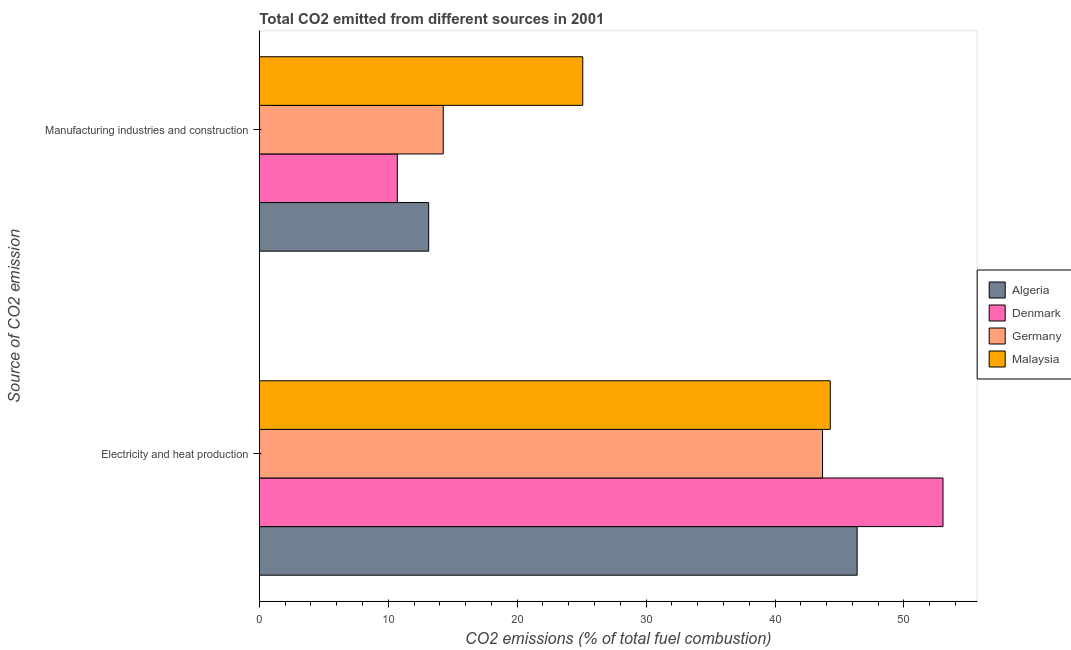How many different coloured bars are there?
Your response must be concise. 4. How many groups of bars are there?
Your response must be concise. 2. Are the number of bars per tick equal to the number of legend labels?
Keep it short and to the point. Yes. Are the number of bars on each tick of the Y-axis equal?
Ensure brevity in your answer.  Yes. How many bars are there on the 1st tick from the top?
Offer a terse response. 4. How many bars are there on the 2nd tick from the bottom?
Provide a succinct answer. 4. What is the label of the 2nd group of bars from the top?
Provide a short and direct response. Electricity and heat production. What is the co2 emissions due to manufacturing industries in Malaysia?
Offer a very short reply. 25.09. Across all countries, what is the maximum co2 emissions due to electricity and heat production?
Offer a terse response. 53.03. Across all countries, what is the minimum co2 emissions due to electricity and heat production?
Make the answer very short. 43.69. In which country was the co2 emissions due to manufacturing industries maximum?
Keep it short and to the point. Malaysia. What is the total co2 emissions due to electricity and heat production in the graph?
Make the answer very short. 187.37. What is the difference between the co2 emissions due to manufacturing industries in Malaysia and that in Denmark?
Your answer should be very brief. 14.38. What is the difference between the co2 emissions due to manufacturing industries in Germany and the co2 emissions due to electricity and heat production in Malaysia?
Give a very brief answer. -30.02. What is the average co2 emissions due to manufacturing industries per country?
Offer a very short reply. 15.8. What is the difference between the co2 emissions due to electricity and heat production and co2 emissions due to manufacturing industries in Malaysia?
Offer a terse response. 19.2. In how many countries, is the co2 emissions due to electricity and heat production greater than 52 %?
Your answer should be very brief. 1. What is the ratio of the co2 emissions due to electricity and heat production in Malaysia to that in Denmark?
Keep it short and to the point. 0.84. Is the co2 emissions due to electricity and heat production in Denmark less than that in Algeria?
Make the answer very short. No. What does the 4th bar from the top in Electricity and heat production represents?
Your answer should be very brief. Algeria. What does the 4th bar from the bottom in Electricity and heat production represents?
Provide a short and direct response. Malaysia. How many bars are there?
Give a very brief answer. 8. Are all the bars in the graph horizontal?
Your response must be concise. Yes. What is the difference between two consecutive major ticks on the X-axis?
Your answer should be compact. 10. Does the graph contain any zero values?
Give a very brief answer. No. How many legend labels are there?
Give a very brief answer. 4. How are the legend labels stacked?
Make the answer very short. Vertical. What is the title of the graph?
Make the answer very short. Total CO2 emitted from different sources in 2001. What is the label or title of the X-axis?
Keep it short and to the point. CO2 emissions (% of total fuel combustion). What is the label or title of the Y-axis?
Your answer should be very brief. Source of CO2 emission. What is the CO2 emissions (% of total fuel combustion) of Algeria in Electricity and heat production?
Give a very brief answer. 46.37. What is the CO2 emissions (% of total fuel combustion) in Denmark in Electricity and heat production?
Provide a succinct answer. 53.03. What is the CO2 emissions (% of total fuel combustion) in Germany in Electricity and heat production?
Provide a succinct answer. 43.69. What is the CO2 emissions (% of total fuel combustion) in Malaysia in Electricity and heat production?
Ensure brevity in your answer.  44.28. What is the CO2 emissions (% of total fuel combustion) of Algeria in Manufacturing industries and construction?
Offer a very short reply. 13.13. What is the CO2 emissions (% of total fuel combustion) of Denmark in Manufacturing industries and construction?
Ensure brevity in your answer.  10.7. What is the CO2 emissions (% of total fuel combustion) in Germany in Manufacturing industries and construction?
Make the answer very short. 14.26. What is the CO2 emissions (% of total fuel combustion) in Malaysia in Manufacturing industries and construction?
Make the answer very short. 25.09. Across all Source of CO2 emission, what is the maximum CO2 emissions (% of total fuel combustion) in Algeria?
Your answer should be very brief. 46.37. Across all Source of CO2 emission, what is the maximum CO2 emissions (% of total fuel combustion) of Denmark?
Offer a very short reply. 53.03. Across all Source of CO2 emission, what is the maximum CO2 emissions (% of total fuel combustion) of Germany?
Offer a terse response. 43.69. Across all Source of CO2 emission, what is the maximum CO2 emissions (% of total fuel combustion) of Malaysia?
Your answer should be very brief. 44.28. Across all Source of CO2 emission, what is the minimum CO2 emissions (% of total fuel combustion) of Algeria?
Offer a terse response. 13.13. Across all Source of CO2 emission, what is the minimum CO2 emissions (% of total fuel combustion) in Denmark?
Provide a succinct answer. 10.7. Across all Source of CO2 emission, what is the minimum CO2 emissions (% of total fuel combustion) in Germany?
Offer a terse response. 14.26. Across all Source of CO2 emission, what is the minimum CO2 emissions (% of total fuel combustion) in Malaysia?
Keep it short and to the point. 25.09. What is the total CO2 emissions (% of total fuel combustion) in Algeria in the graph?
Offer a very short reply. 59.5. What is the total CO2 emissions (% of total fuel combustion) in Denmark in the graph?
Offer a very short reply. 63.73. What is the total CO2 emissions (% of total fuel combustion) in Germany in the graph?
Offer a very short reply. 57.95. What is the total CO2 emissions (% of total fuel combustion) of Malaysia in the graph?
Keep it short and to the point. 69.37. What is the difference between the CO2 emissions (% of total fuel combustion) in Algeria in Electricity and heat production and that in Manufacturing industries and construction?
Offer a very short reply. 33.24. What is the difference between the CO2 emissions (% of total fuel combustion) in Denmark in Electricity and heat production and that in Manufacturing industries and construction?
Your response must be concise. 42.33. What is the difference between the CO2 emissions (% of total fuel combustion) of Germany in Electricity and heat production and that in Manufacturing industries and construction?
Your answer should be compact. 29.42. What is the difference between the CO2 emissions (% of total fuel combustion) in Malaysia in Electricity and heat production and that in Manufacturing industries and construction?
Provide a short and direct response. 19.2. What is the difference between the CO2 emissions (% of total fuel combustion) in Algeria in Electricity and heat production and the CO2 emissions (% of total fuel combustion) in Denmark in Manufacturing industries and construction?
Your answer should be very brief. 35.67. What is the difference between the CO2 emissions (% of total fuel combustion) of Algeria in Electricity and heat production and the CO2 emissions (% of total fuel combustion) of Germany in Manufacturing industries and construction?
Make the answer very short. 32.11. What is the difference between the CO2 emissions (% of total fuel combustion) of Algeria in Electricity and heat production and the CO2 emissions (% of total fuel combustion) of Malaysia in Manufacturing industries and construction?
Your answer should be very brief. 21.29. What is the difference between the CO2 emissions (% of total fuel combustion) of Denmark in Electricity and heat production and the CO2 emissions (% of total fuel combustion) of Germany in Manufacturing industries and construction?
Your answer should be very brief. 38.76. What is the difference between the CO2 emissions (% of total fuel combustion) in Denmark in Electricity and heat production and the CO2 emissions (% of total fuel combustion) in Malaysia in Manufacturing industries and construction?
Offer a terse response. 27.94. What is the difference between the CO2 emissions (% of total fuel combustion) in Germany in Electricity and heat production and the CO2 emissions (% of total fuel combustion) in Malaysia in Manufacturing industries and construction?
Your answer should be compact. 18.6. What is the average CO2 emissions (% of total fuel combustion) in Algeria per Source of CO2 emission?
Provide a short and direct response. 29.75. What is the average CO2 emissions (% of total fuel combustion) of Denmark per Source of CO2 emission?
Provide a short and direct response. 31.87. What is the average CO2 emissions (% of total fuel combustion) in Germany per Source of CO2 emission?
Provide a short and direct response. 28.98. What is the average CO2 emissions (% of total fuel combustion) in Malaysia per Source of CO2 emission?
Give a very brief answer. 34.69. What is the difference between the CO2 emissions (% of total fuel combustion) in Algeria and CO2 emissions (% of total fuel combustion) in Denmark in Electricity and heat production?
Ensure brevity in your answer.  -6.66. What is the difference between the CO2 emissions (% of total fuel combustion) in Algeria and CO2 emissions (% of total fuel combustion) in Germany in Electricity and heat production?
Your response must be concise. 2.68. What is the difference between the CO2 emissions (% of total fuel combustion) in Algeria and CO2 emissions (% of total fuel combustion) in Malaysia in Electricity and heat production?
Your answer should be compact. 2.09. What is the difference between the CO2 emissions (% of total fuel combustion) of Denmark and CO2 emissions (% of total fuel combustion) of Germany in Electricity and heat production?
Your answer should be very brief. 9.34. What is the difference between the CO2 emissions (% of total fuel combustion) of Denmark and CO2 emissions (% of total fuel combustion) of Malaysia in Electricity and heat production?
Keep it short and to the point. 8.74. What is the difference between the CO2 emissions (% of total fuel combustion) in Germany and CO2 emissions (% of total fuel combustion) in Malaysia in Electricity and heat production?
Provide a short and direct response. -0.6. What is the difference between the CO2 emissions (% of total fuel combustion) in Algeria and CO2 emissions (% of total fuel combustion) in Denmark in Manufacturing industries and construction?
Your answer should be very brief. 2.43. What is the difference between the CO2 emissions (% of total fuel combustion) of Algeria and CO2 emissions (% of total fuel combustion) of Germany in Manufacturing industries and construction?
Ensure brevity in your answer.  -1.13. What is the difference between the CO2 emissions (% of total fuel combustion) in Algeria and CO2 emissions (% of total fuel combustion) in Malaysia in Manufacturing industries and construction?
Ensure brevity in your answer.  -11.95. What is the difference between the CO2 emissions (% of total fuel combustion) in Denmark and CO2 emissions (% of total fuel combustion) in Germany in Manufacturing industries and construction?
Your response must be concise. -3.56. What is the difference between the CO2 emissions (% of total fuel combustion) of Denmark and CO2 emissions (% of total fuel combustion) of Malaysia in Manufacturing industries and construction?
Offer a very short reply. -14.38. What is the difference between the CO2 emissions (% of total fuel combustion) in Germany and CO2 emissions (% of total fuel combustion) in Malaysia in Manufacturing industries and construction?
Keep it short and to the point. -10.82. What is the ratio of the CO2 emissions (% of total fuel combustion) in Algeria in Electricity and heat production to that in Manufacturing industries and construction?
Offer a terse response. 3.53. What is the ratio of the CO2 emissions (% of total fuel combustion) in Denmark in Electricity and heat production to that in Manufacturing industries and construction?
Your answer should be very brief. 4.96. What is the ratio of the CO2 emissions (% of total fuel combustion) in Germany in Electricity and heat production to that in Manufacturing industries and construction?
Your response must be concise. 3.06. What is the ratio of the CO2 emissions (% of total fuel combustion) of Malaysia in Electricity and heat production to that in Manufacturing industries and construction?
Offer a very short reply. 1.77. What is the difference between the highest and the second highest CO2 emissions (% of total fuel combustion) in Algeria?
Your answer should be compact. 33.24. What is the difference between the highest and the second highest CO2 emissions (% of total fuel combustion) in Denmark?
Give a very brief answer. 42.33. What is the difference between the highest and the second highest CO2 emissions (% of total fuel combustion) of Germany?
Provide a short and direct response. 29.42. What is the difference between the highest and the second highest CO2 emissions (% of total fuel combustion) of Malaysia?
Keep it short and to the point. 19.2. What is the difference between the highest and the lowest CO2 emissions (% of total fuel combustion) in Algeria?
Ensure brevity in your answer.  33.24. What is the difference between the highest and the lowest CO2 emissions (% of total fuel combustion) in Denmark?
Ensure brevity in your answer.  42.33. What is the difference between the highest and the lowest CO2 emissions (% of total fuel combustion) of Germany?
Offer a very short reply. 29.42. What is the difference between the highest and the lowest CO2 emissions (% of total fuel combustion) of Malaysia?
Your response must be concise. 19.2. 